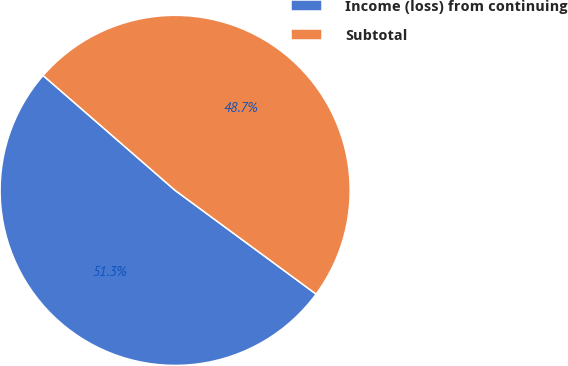<chart> <loc_0><loc_0><loc_500><loc_500><pie_chart><fcel>Income (loss) from continuing<fcel>Subtotal<nl><fcel>51.3%<fcel>48.7%<nl></chart> 